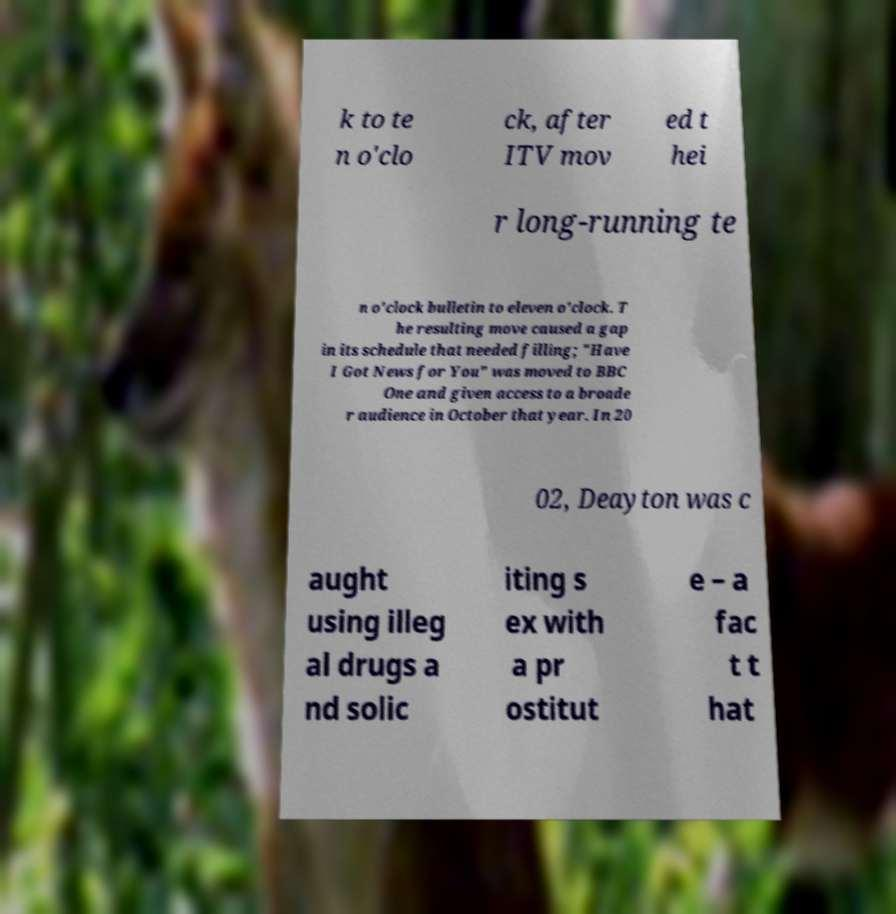Please read and relay the text visible in this image. What does it say? k to te n o'clo ck, after ITV mov ed t hei r long-running te n o'clock bulletin to eleven o'clock. T he resulting move caused a gap in its schedule that needed filling; "Have I Got News for You" was moved to BBC One and given access to a broade r audience in October that year. In 20 02, Deayton was c aught using illeg al drugs a nd solic iting s ex with a pr ostitut e – a fac t t hat 